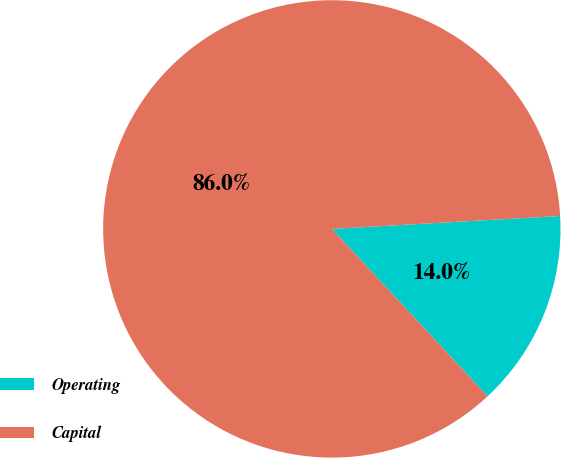<chart> <loc_0><loc_0><loc_500><loc_500><pie_chart><fcel>Operating<fcel>Capital<nl><fcel>13.97%<fcel>86.03%<nl></chart> 